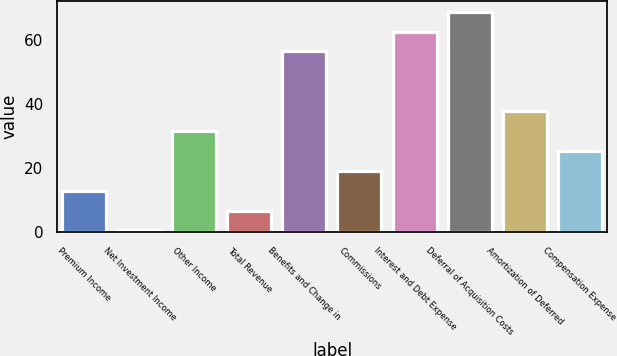Convert chart. <chart><loc_0><loc_0><loc_500><loc_500><bar_chart><fcel>Premium Income<fcel>Net Investment Income<fcel>Other Income<fcel>Total Revenue<fcel>Benefits and Change in<fcel>Commissions<fcel>Interest and Debt Expense<fcel>Deferral of Acquisition Costs<fcel>Amortization of Deferred<fcel>Compensation Expense<nl><fcel>12.98<fcel>0.6<fcel>31.55<fcel>6.79<fcel>56.31<fcel>19.17<fcel>62.5<fcel>68.69<fcel>37.74<fcel>25.36<nl></chart> 